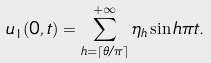<formula> <loc_0><loc_0><loc_500><loc_500>u _ { 1 } ( 0 , t ) = \sum _ { h = \lceil \theta / \pi \rceil } ^ { + \infty } \eta _ { h } \sin h \pi t .</formula> 